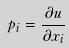Convert formula to latex. <formula><loc_0><loc_0><loc_500><loc_500>p _ { i } = \frac { \partial u } { \partial x _ { i } }</formula> 